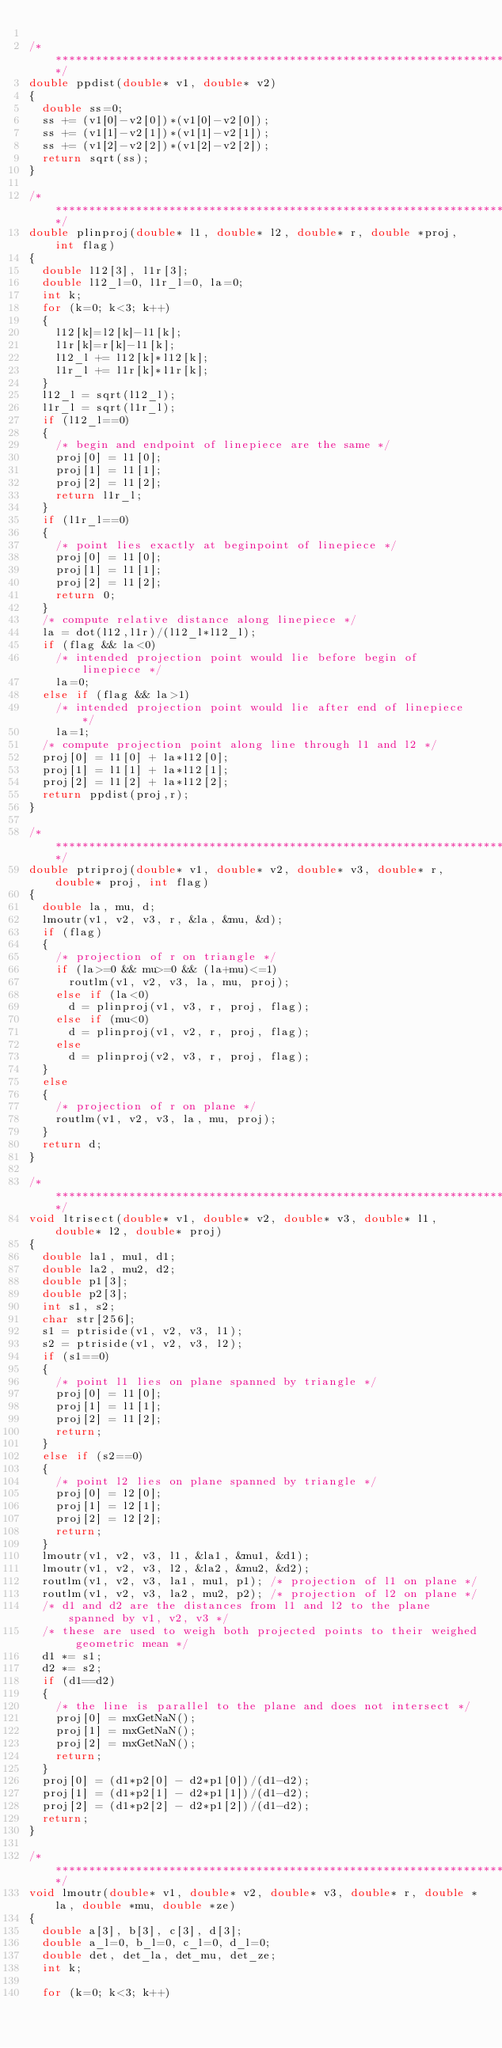<code> <loc_0><loc_0><loc_500><loc_500><_C_>
/****************************************************************************/
double ppdist(double* v1, double* v2)
{
  double ss=0;
  ss += (v1[0]-v2[0])*(v1[0]-v2[0]);
  ss += (v1[1]-v2[1])*(v1[1]-v2[1]);
  ss += (v1[2]-v2[2])*(v1[2]-v2[2]);
  return sqrt(ss);
}

/****************************************************************************/
double plinproj(double* l1, double* l2, double* r, double *proj, int flag)
{
  double l12[3], l1r[3];
  double l12_l=0, l1r_l=0, la=0;
  int k;
  for (k=0; k<3; k++)
  {
    l12[k]=l2[k]-l1[k];
    l1r[k]=r[k]-l1[k];
    l12_l += l12[k]*l12[k];
    l1r_l += l1r[k]*l1r[k];
  }
  l12_l = sqrt(l12_l);
  l1r_l = sqrt(l1r_l);
  if (l12_l==0)
  {
    /* begin and endpoint of linepiece are the same */
    proj[0] = l1[0];
    proj[1] = l1[1];
    proj[2] = l1[2];
    return l1r_l;
  }
  if (l1r_l==0)
  {
    /* point lies exactly at beginpoint of linepiece */
    proj[0] = l1[0];
    proj[1] = l1[1];
    proj[2] = l1[2];
    return 0;
  }
  /* compute relative distance along linepiece */
  la = dot(l12,l1r)/(l12_l*l12_l);
  if (flag && la<0)
    /* intended projection point would lie before begin of linepiece */
    la=0;
  else if (flag && la>1)
    /* intended projection point would lie after end of linepiece */
    la=1;
  /* compute projection point along line through l1 and l2 */
  proj[0] = l1[0] + la*l12[0];
  proj[1] = l1[1] + la*l12[1];
  proj[2] = l1[2] + la*l12[2];
  return ppdist(proj,r);
}

/****************************************************************************/
double ptriproj(double* v1, double* v2, double* v3, double* r, double* proj, int flag)
{
  double la, mu, d;
  lmoutr(v1, v2, v3, r, &la, &mu, &d);
  if (flag)
  {
    /* projection of r on triangle */
    if (la>=0 && mu>=0 && (la+mu)<=1)
      routlm(v1, v2, v3, la, mu, proj);
    else if (la<0)
      d = plinproj(v1, v3, r, proj, flag);
    else if (mu<0)
      d = plinproj(v1, v2, r, proj, flag);
    else
      d = plinproj(v2, v3, r, proj, flag);
  }
  else
  {
    /* projection of r on plane */
    routlm(v1, v2, v3, la, mu, proj);
  }
  return d;
}

/****************************************************************************/
void ltrisect(double* v1, double* v2, double* v3, double* l1, double* l2, double* proj)
{
  double la1, mu1, d1;
  double la2, mu2, d2;
  double p1[3];
  double p2[3];
  int s1, s2;
  char str[256];
  s1 = ptriside(v1, v2, v3, l1);
  s2 = ptriside(v1, v2, v3, l2);
  if (s1==0)
  {
    /* point l1 lies on plane spanned by triangle */
    proj[0] = l1[0];
    proj[1] = l1[1];
    proj[2] = l1[2];
    return;
  }
  else if (s2==0)
  {
    /* point l2 lies on plane spanned by triangle */
    proj[0] = l2[0];
    proj[1] = l2[1];
    proj[2] = l2[2];
    return;
  }
  lmoutr(v1, v2, v3, l1, &la1, &mu1, &d1);
  lmoutr(v1, v2, v3, l2, &la2, &mu2, &d2);
  routlm(v1, v2, v3, la1, mu1, p1);	/* projection of l1 on plane */
  routlm(v1, v2, v3, la2, mu2, p2);	/* projection of l2 on plane */
  /* d1 and d2 are the distances from l1 and l2 to the plane spanned by v1, v2, v3 */
  /* these are used to weigh both projected points to their weighed geometric mean */
  d1 *= s1;
  d2 *= s2;
  if (d1==d2)
  {
    /* the line is parallel to the plane and does not intersect */
    proj[0] = mxGetNaN();
    proj[1] = mxGetNaN();
    proj[2] = mxGetNaN();
    return;
  }
  proj[0] = (d1*p2[0] - d2*p1[0])/(d1-d2);
  proj[1] = (d1*p2[1] - d2*p1[1])/(d1-d2);
  proj[2] = (d1*p2[2] - d2*p1[2])/(d1-d2);
  return;
}

/****************************************************************************/
void lmoutr(double* v1, double* v2, double* v3, double* r, double *la, double *mu, double *ze)
{
  double a[3], b[3], c[3], d[3];
  double a_l=0, b_l=0, c_l=0, d_l=0;
  double det, det_la, det_mu, det_ze;
  int k;

  for (k=0; k<3; k++)</code> 